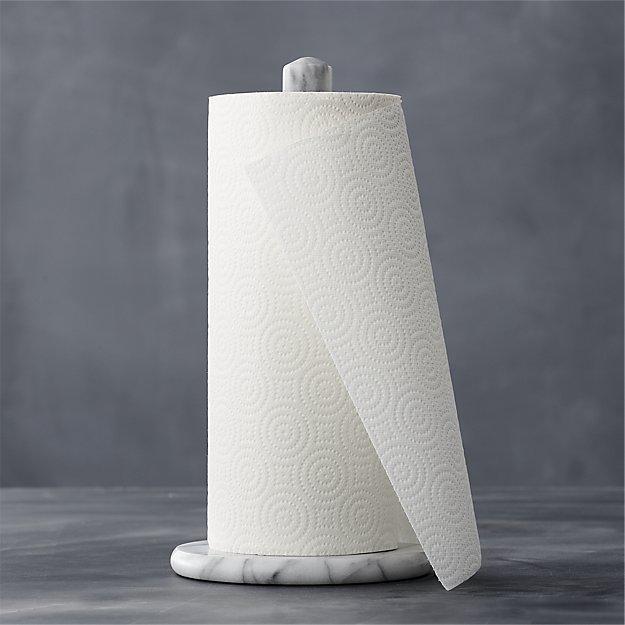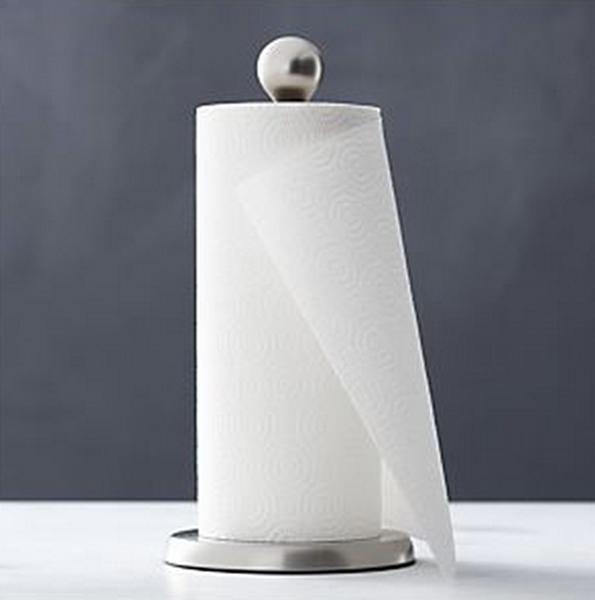The first image is the image on the left, the second image is the image on the right. For the images shown, is this caption "There is exactly one roll of paper towels in the image on the left." true? Answer yes or no. Yes. 